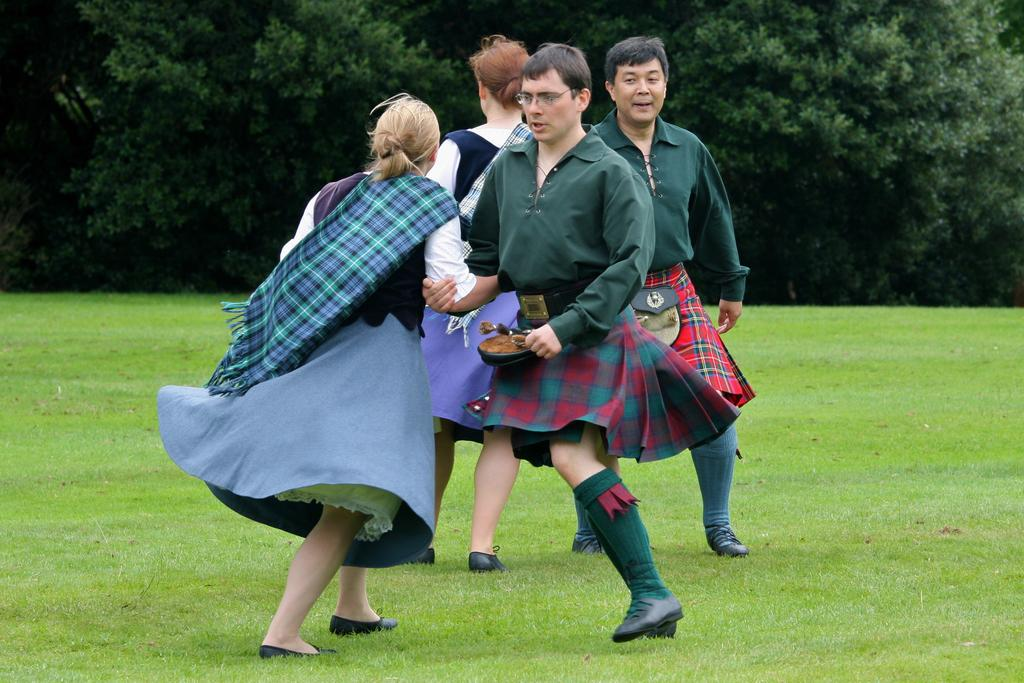Who or what is present in the image? There are people in the image. Where are the people located? The people are on the grass. What can be seen in the background of the image? There are trees visible in the image. What type of bell can be heard ringing in the image? There is no bell present in the image, and therefore no sound can be heard. 